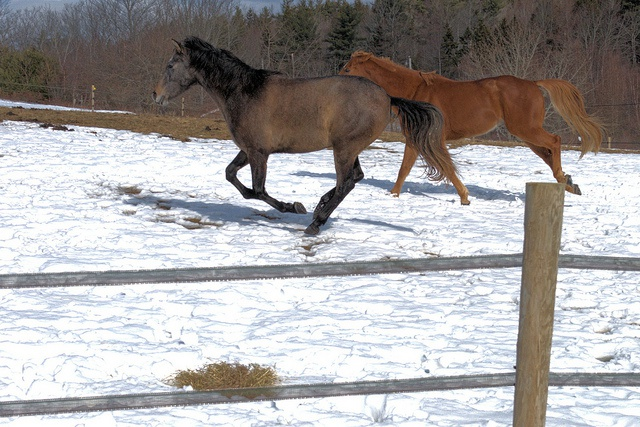Describe the objects in this image and their specific colors. I can see horse in gray, black, and maroon tones and horse in gray, maroon, and brown tones in this image. 